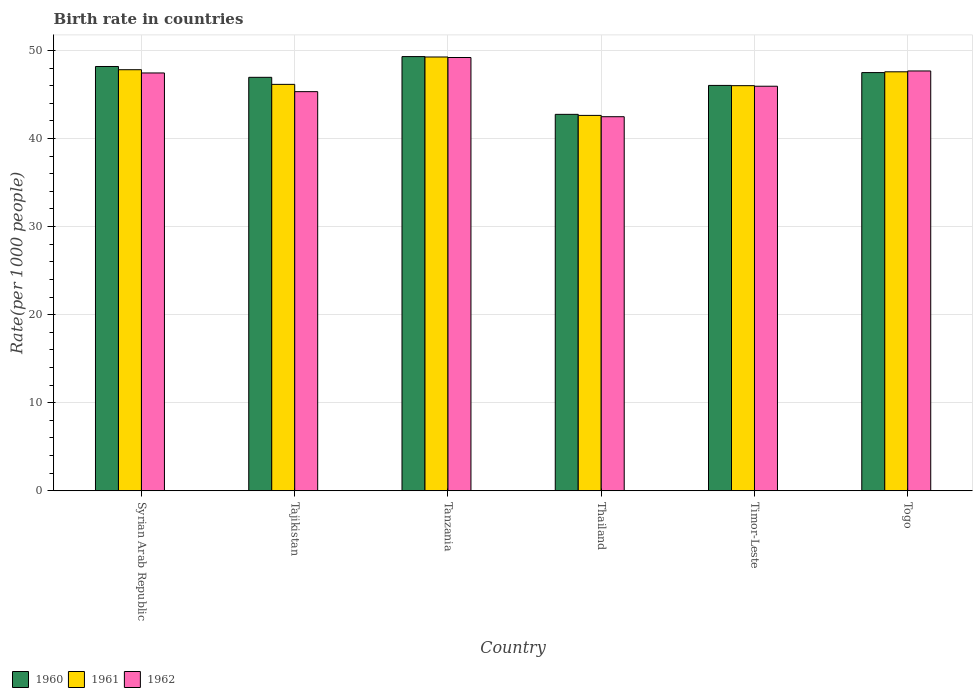How many different coloured bars are there?
Ensure brevity in your answer.  3. Are the number of bars per tick equal to the number of legend labels?
Your answer should be very brief. Yes. Are the number of bars on each tick of the X-axis equal?
Provide a short and direct response. Yes. How many bars are there on the 6th tick from the left?
Offer a terse response. 3. What is the label of the 5th group of bars from the left?
Your answer should be compact. Timor-Leste. What is the birth rate in 1962 in Thailand?
Give a very brief answer. 42.47. Across all countries, what is the maximum birth rate in 1960?
Your answer should be very brief. 49.3. Across all countries, what is the minimum birth rate in 1962?
Offer a very short reply. 42.47. In which country was the birth rate in 1961 maximum?
Your answer should be compact. Tanzania. In which country was the birth rate in 1960 minimum?
Provide a short and direct response. Thailand. What is the total birth rate in 1961 in the graph?
Your answer should be compact. 279.38. What is the difference between the birth rate in 1961 in Thailand and that in Togo?
Make the answer very short. -4.95. What is the difference between the birth rate in 1961 in Tajikistan and the birth rate in 1960 in Timor-Leste?
Provide a succinct answer. 0.12. What is the average birth rate in 1960 per country?
Provide a short and direct response. 46.77. What is the difference between the birth rate of/in 1962 and birth rate of/in 1960 in Tajikistan?
Offer a very short reply. -1.63. In how many countries, is the birth rate in 1962 greater than 46?
Provide a succinct answer. 3. What is the ratio of the birth rate in 1962 in Syrian Arab Republic to that in Thailand?
Your response must be concise. 1.12. Is the birth rate in 1961 in Syrian Arab Republic less than that in Tajikistan?
Your response must be concise. No. What is the difference between the highest and the second highest birth rate in 1962?
Offer a terse response. 1.75. What is the difference between the highest and the lowest birth rate in 1960?
Provide a short and direct response. 6.56. What does the 3rd bar from the right in Tanzania represents?
Provide a short and direct response. 1960. How many bars are there?
Provide a succinct answer. 18. Are all the bars in the graph horizontal?
Provide a short and direct response. No. What is the difference between two consecutive major ticks on the Y-axis?
Provide a succinct answer. 10. Does the graph contain any zero values?
Make the answer very short. No. How are the legend labels stacked?
Ensure brevity in your answer.  Horizontal. What is the title of the graph?
Ensure brevity in your answer.  Birth rate in countries. Does "1964" appear as one of the legend labels in the graph?
Your response must be concise. No. What is the label or title of the Y-axis?
Your answer should be compact. Rate(per 1000 people). What is the Rate(per 1000 people) of 1960 in Syrian Arab Republic?
Your response must be concise. 48.17. What is the Rate(per 1000 people) of 1961 in Syrian Arab Republic?
Your answer should be compact. 47.8. What is the Rate(per 1000 people) in 1962 in Syrian Arab Republic?
Give a very brief answer. 47.44. What is the Rate(per 1000 people) in 1960 in Tajikistan?
Your answer should be very brief. 46.94. What is the Rate(per 1000 people) in 1961 in Tajikistan?
Offer a very short reply. 46.14. What is the Rate(per 1000 people) of 1962 in Tajikistan?
Offer a terse response. 45.31. What is the Rate(per 1000 people) in 1960 in Tanzania?
Ensure brevity in your answer.  49.3. What is the Rate(per 1000 people) in 1961 in Tanzania?
Provide a short and direct response. 49.25. What is the Rate(per 1000 people) in 1962 in Tanzania?
Ensure brevity in your answer.  49.19. What is the Rate(per 1000 people) in 1960 in Thailand?
Offer a very short reply. 42.74. What is the Rate(per 1000 people) in 1961 in Thailand?
Make the answer very short. 42.62. What is the Rate(per 1000 people) in 1962 in Thailand?
Make the answer very short. 42.47. What is the Rate(per 1000 people) in 1960 in Timor-Leste?
Provide a short and direct response. 46.02. What is the Rate(per 1000 people) in 1961 in Timor-Leste?
Ensure brevity in your answer.  45.99. What is the Rate(per 1000 people) in 1962 in Timor-Leste?
Make the answer very short. 45.93. What is the Rate(per 1000 people) of 1960 in Togo?
Keep it short and to the point. 47.48. What is the Rate(per 1000 people) in 1961 in Togo?
Your answer should be compact. 47.57. What is the Rate(per 1000 people) in 1962 in Togo?
Make the answer very short. 47.66. Across all countries, what is the maximum Rate(per 1000 people) of 1960?
Your answer should be very brief. 49.3. Across all countries, what is the maximum Rate(per 1000 people) of 1961?
Ensure brevity in your answer.  49.25. Across all countries, what is the maximum Rate(per 1000 people) of 1962?
Your response must be concise. 49.19. Across all countries, what is the minimum Rate(per 1000 people) in 1960?
Give a very brief answer. 42.74. Across all countries, what is the minimum Rate(per 1000 people) in 1961?
Ensure brevity in your answer.  42.62. Across all countries, what is the minimum Rate(per 1000 people) in 1962?
Your response must be concise. 42.47. What is the total Rate(per 1000 people) of 1960 in the graph?
Offer a terse response. 280.65. What is the total Rate(per 1000 people) in 1961 in the graph?
Your response must be concise. 279.38. What is the total Rate(per 1000 people) of 1962 in the graph?
Ensure brevity in your answer.  278.01. What is the difference between the Rate(per 1000 people) in 1960 in Syrian Arab Republic and that in Tajikistan?
Ensure brevity in your answer.  1.23. What is the difference between the Rate(per 1000 people) in 1961 in Syrian Arab Republic and that in Tajikistan?
Keep it short and to the point. 1.66. What is the difference between the Rate(per 1000 people) in 1962 in Syrian Arab Republic and that in Tajikistan?
Your answer should be very brief. 2.12. What is the difference between the Rate(per 1000 people) in 1960 in Syrian Arab Republic and that in Tanzania?
Provide a succinct answer. -1.12. What is the difference between the Rate(per 1000 people) of 1961 in Syrian Arab Republic and that in Tanzania?
Offer a very short reply. -1.44. What is the difference between the Rate(per 1000 people) in 1962 in Syrian Arab Republic and that in Tanzania?
Give a very brief answer. -1.75. What is the difference between the Rate(per 1000 people) of 1960 in Syrian Arab Republic and that in Thailand?
Keep it short and to the point. 5.43. What is the difference between the Rate(per 1000 people) of 1961 in Syrian Arab Republic and that in Thailand?
Give a very brief answer. 5.19. What is the difference between the Rate(per 1000 people) in 1962 in Syrian Arab Republic and that in Thailand?
Keep it short and to the point. 4.97. What is the difference between the Rate(per 1000 people) of 1960 in Syrian Arab Republic and that in Timor-Leste?
Offer a terse response. 2.15. What is the difference between the Rate(per 1000 people) of 1961 in Syrian Arab Republic and that in Timor-Leste?
Your response must be concise. 1.81. What is the difference between the Rate(per 1000 people) of 1962 in Syrian Arab Republic and that in Timor-Leste?
Your answer should be compact. 1.51. What is the difference between the Rate(per 1000 people) in 1960 in Syrian Arab Republic and that in Togo?
Ensure brevity in your answer.  0.69. What is the difference between the Rate(per 1000 people) in 1961 in Syrian Arab Republic and that in Togo?
Make the answer very short. 0.24. What is the difference between the Rate(per 1000 people) of 1962 in Syrian Arab Republic and that in Togo?
Offer a very short reply. -0.23. What is the difference between the Rate(per 1000 people) of 1960 in Tajikistan and that in Tanzania?
Offer a terse response. -2.35. What is the difference between the Rate(per 1000 people) in 1961 in Tajikistan and that in Tanzania?
Your answer should be very brief. -3.11. What is the difference between the Rate(per 1000 people) of 1962 in Tajikistan and that in Tanzania?
Your answer should be very brief. -3.88. What is the difference between the Rate(per 1000 people) of 1960 in Tajikistan and that in Thailand?
Your answer should be compact. 4.21. What is the difference between the Rate(per 1000 people) in 1961 in Tajikistan and that in Thailand?
Keep it short and to the point. 3.52. What is the difference between the Rate(per 1000 people) of 1962 in Tajikistan and that in Thailand?
Provide a short and direct response. 2.85. What is the difference between the Rate(per 1000 people) of 1960 in Tajikistan and that in Timor-Leste?
Provide a short and direct response. 0.92. What is the difference between the Rate(per 1000 people) in 1961 in Tajikistan and that in Timor-Leste?
Give a very brief answer. 0.15. What is the difference between the Rate(per 1000 people) of 1962 in Tajikistan and that in Timor-Leste?
Your response must be concise. -0.61. What is the difference between the Rate(per 1000 people) in 1960 in Tajikistan and that in Togo?
Your answer should be compact. -0.54. What is the difference between the Rate(per 1000 people) in 1961 in Tajikistan and that in Togo?
Provide a succinct answer. -1.43. What is the difference between the Rate(per 1000 people) in 1962 in Tajikistan and that in Togo?
Offer a terse response. -2.35. What is the difference between the Rate(per 1000 people) in 1960 in Tanzania and that in Thailand?
Give a very brief answer. 6.56. What is the difference between the Rate(per 1000 people) in 1961 in Tanzania and that in Thailand?
Provide a succinct answer. 6.63. What is the difference between the Rate(per 1000 people) of 1962 in Tanzania and that in Thailand?
Make the answer very short. 6.72. What is the difference between the Rate(per 1000 people) in 1960 in Tanzania and that in Timor-Leste?
Provide a succinct answer. 3.27. What is the difference between the Rate(per 1000 people) in 1961 in Tanzania and that in Timor-Leste?
Offer a terse response. 3.25. What is the difference between the Rate(per 1000 people) of 1962 in Tanzania and that in Timor-Leste?
Your answer should be very brief. 3.26. What is the difference between the Rate(per 1000 people) of 1960 in Tanzania and that in Togo?
Ensure brevity in your answer.  1.82. What is the difference between the Rate(per 1000 people) of 1961 in Tanzania and that in Togo?
Your answer should be compact. 1.68. What is the difference between the Rate(per 1000 people) in 1962 in Tanzania and that in Togo?
Your response must be concise. 1.53. What is the difference between the Rate(per 1000 people) of 1960 in Thailand and that in Timor-Leste?
Keep it short and to the point. -3.29. What is the difference between the Rate(per 1000 people) in 1961 in Thailand and that in Timor-Leste?
Give a very brief answer. -3.38. What is the difference between the Rate(per 1000 people) of 1962 in Thailand and that in Timor-Leste?
Give a very brief answer. -3.46. What is the difference between the Rate(per 1000 people) of 1960 in Thailand and that in Togo?
Your answer should be very brief. -4.74. What is the difference between the Rate(per 1000 people) of 1961 in Thailand and that in Togo?
Offer a terse response. -4.95. What is the difference between the Rate(per 1000 people) in 1962 in Thailand and that in Togo?
Your answer should be compact. -5.19. What is the difference between the Rate(per 1000 people) of 1960 in Timor-Leste and that in Togo?
Provide a succinct answer. -1.46. What is the difference between the Rate(per 1000 people) of 1961 in Timor-Leste and that in Togo?
Offer a very short reply. -1.57. What is the difference between the Rate(per 1000 people) of 1962 in Timor-Leste and that in Togo?
Your answer should be compact. -1.73. What is the difference between the Rate(per 1000 people) of 1960 in Syrian Arab Republic and the Rate(per 1000 people) of 1961 in Tajikistan?
Provide a short and direct response. 2.03. What is the difference between the Rate(per 1000 people) of 1960 in Syrian Arab Republic and the Rate(per 1000 people) of 1962 in Tajikistan?
Offer a terse response. 2.86. What is the difference between the Rate(per 1000 people) in 1961 in Syrian Arab Republic and the Rate(per 1000 people) in 1962 in Tajikistan?
Ensure brevity in your answer.  2.49. What is the difference between the Rate(per 1000 people) of 1960 in Syrian Arab Republic and the Rate(per 1000 people) of 1961 in Tanzania?
Offer a terse response. -1.08. What is the difference between the Rate(per 1000 people) in 1960 in Syrian Arab Republic and the Rate(per 1000 people) in 1962 in Tanzania?
Provide a succinct answer. -1.02. What is the difference between the Rate(per 1000 people) in 1961 in Syrian Arab Republic and the Rate(per 1000 people) in 1962 in Tanzania?
Your answer should be very brief. -1.39. What is the difference between the Rate(per 1000 people) in 1960 in Syrian Arab Republic and the Rate(per 1000 people) in 1961 in Thailand?
Your answer should be compact. 5.55. What is the difference between the Rate(per 1000 people) of 1960 in Syrian Arab Republic and the Rate(per 1000 people) of 1962 in Thailand?
Make the answer very short. 5.7. What is the difference between the Rate(per 1000 people) of 1961 in Syrian Arab Republic and the Rate(per 1000 people) of 1962 in Thailand?
Make the answer very short. 5.33. What is the difference between the Rate(per 1000 people) of 1960 in Syrian Arab Republic and the Rate(per 1000 people) of 1961 in Timor-Leste?
Your answer should be compact. 2.18. What is the difference between the Rate(per 1000 people) of 1960 in Syrian Arab Republic and the Rate(per 1000 people) of 1962 in Timor-Leste?
Your response must be concise. 2.24. What is the difference between the Rate(per 1000 people) of 1961 in Syrian Arab Republic and the Rate(per 1000 people) of 1962 in Timor-Leste?
Give a very brief answer. 1.88. What is the difference between the Rate(per 1000 people) in 1960 in Syrian Arab Republic and the Rate(per 1000 people) in 1961 in Togo?
Give a very brief answer. 0.6. What is the difference between the Rate(per 1000 people) in 1960 in Syrian Arab Republic and the Rate(per 1000 people) in 1962 in Togo?
Offer a terse response. 0.51. What is the difference between the Rate(per 1000 people) in 1961 in Syrian Arab Republic and the Rate(per 1000 people) in 1962 in Togo?
Keep it short and to the point. 0.14. What is the difference between the Rate(per 1000 people) of 1960 in Tajikistan and the Rate(per 1000 people) of 1961 in Tanzania?
Your answer should be compact. -2.31. What is the difference between the Rate(per 1000 people) in 1960 in Tajikistan and the Rate(per 1000 people) in 1962 in Tanzania?
Your answer should be compact. -2.25. What is the difference between the Rate(per 1000 people) in 1961 in Tajikistan and the Rate(per 1000 people) in 1962 in Tanzania?
Your answer should be compact. -3.05. What is the difference between the Rate(per 1000 people) in 1960 in Tajikistan and the Rate(per 1000 people) in 1961 in Thailand?
Offer a very short reply. 4.32. What is the difference between the Rate(per 1000 people) in 1960 in Tajikistan and the Rate(per 1000 people) in 1962 in Thailand?
Offer a terse response. 4.47. What is the difference between the Rate(per 1000 people) in 1961 in Tajikistan and the Rate(per 1000 people) in 1962 in Thailand?
Provide a short and direct response. 3.67. What is the difference between the Rate(per 1000 people) in 1960 in Tajikistan and the Rate(per 1000 people) in 1961 in Timor-Leste?
Your answer should be very brief. 0.95. What is the difference between the Rate(per 1000 people) in 1960 in Tajikistan and the Rate(per 1000 people) in 1962 in Timor-Leste?
Provide a short and direct response. 1.01. What is the difference between the Rate(per 1000 people) in 1961 in Tajikistan and the Rate(per 1000 people) in 1962 in Timor-Leste?
Your answer should be compact. 0.21. What is the difference between the Rate(per 1000 people) in 1960 in Tajikistan and the Rate(per 1000 people) in 1961 in Togo?
Offer a very short reply. -0.63. What is the difference between the Rate(per 1000 people) of 1960 in Tajikistan and the Rate(per 1000 people) of 1962 in Togo?
Make the answer very short. -0.72. What is the difference between the Rate(per 1000 people) in 1961 in Tajikistan and the Rate(per 1000 people) in 1962 in Togo?
Offer a terse response. -1.52. What is the difference between the Rate(per 1000 people) in 1960 in Tanzania and the Rate(per 1000 people) in 1961 in Thailand?
Give a very brief answer. 6.68. What is the difference between the Rate(per 1000 people) in 1960 in Tanzania and the Rate(per 1000 people) in 1962 in Thailand?
Your answer should be compact. 6.83. What is the difference between the Rate(per 1000 people) in 1961 in Tanzania and the Rate(per 1000 people) in 1962 in Thailand?
Offer a terse response. 6.78. What is the difference between the Rate(per 1000 people) in 1960 in Tanzania and the Rate(per 1000 people) in 1961 in Timor-Leste?
Provide a succinct answer. 3.3. What is the difference between the Rate(per 1000 people) of 1960 in Tanzania and the Rate(per 1000 people) of 1962 in Timor-Leste?
Make the answer very short. 3.37. What is the difference between the Rate(per 1000 people) in 1961 in Tanzania and the Rate(per 1000 people) in 1962 in Timor-Leste?
Your response must be concise. 3.32. What is the difference between the Rate(per 1000 people) of 1960 in Tanzania and the Rate(per 1000 people) of 1961 in Togo?
Your answer should be very brief. 1.73. What is the difference between the Rate(per 1000 people) of 1960 in Tanzania and the Rate(per 1000 people) of 1962 in Togo?
Give a very brief answer. 1.63. What is the difference between the Rate(per 1000 people) of 1961 in Tanzania and the Rate(per 1000 people) of 1962 in Togo?
Make the answer very short. 1.59. What is the difference between the Rate(per 1000 people) of 1960 in Thailand and the Rate(per 1000 people) of 1961 in Timor-Leste?
Offer a terse response. -3.26. What is the difference between the Rate(per 1000 people) in 1960 in Thailand and the Rate(per 1000 people) in 1962 in Timor-Leste?
Provide a short and direct response. -3.19. What is the difference between the Rate(per 1000 people) of 1961 in Thailand and the Rate(per 1000 people) of 1962 in Timor-Leste?
Provide a succinct answer. -3.31. What is the difference between the Rate(per 1000 people) of 1960 in Thailand and the Rate(per 1000 people) of 1961 in Togo?
Your answer should be very brief. -4.83. What is the difference between the Rate(per 1000 people) of 1960 in Thailand and the Rate(per 1000 people) of 1962 in Togo?
Make the answer very short. -4.93. What is the difference between the Rate(per 1000 people) in 1961 in Thailand and the Rate(per 1000 people) in 1962 in Togo?
Your answer should be very brief. -5.04. What is the difference between the Rate(per 1000 people) in 1960 in Timor-Leste and the Rate(per 1000 people) in 1961 in Togo?
Your response must be concise. -1.54. What is the difference between the Rate(per 1000 people) of 1960 in Timor-Leste and the Rate(per 1000 people) of 1962 in Togo?
Make the answer very short. -1.64. What is the difference between the Rate(per 1000 people) in 1961 in Timor-Leste and the Rate(per 1000 people) in 1962 in Togo?
Keep it short and to the point. -1.67. What is the average Rate(per 1000 people) of 1960 per country?
Ensure brevity in your answer.  46.77. What is the average Rate(per 1000 people) in 1961 per country?
Offer a very short reply. 46.56. What is the average Rate(per 1000 people) in 1962 per country?
Give a very brief answer. 46.33. What is the difference between the Rate(per 1000 people) of 1960 and Rate(per 1000 people) of 1961 in Syrian Arab Republic?
Offer a terse response. 0.37. What is the difference between the Rate(per 1000 people) in 1960 and Rate(per 1000 people) in 1962 in Syrian Arab Republic?
Keep it short and to the point. 0.73. What is the difference between the Rate(per 1000 people) of 1961 and Rate(per 1000 people) of 1962 in Syrian Arab Republic?
Keep it short and to the point. 0.37. What is the difference between the Rate(per 1000 people) of 1960 and Rate(per 1000 people) of 1962 in Tajikistan?
Provide a short and direct response. 1.63. What is the difference between the Rate(per 1000 people) of 1961 and Rate(per 1000 people) of 1962 in Tajikistan?
Your answer should be compact. 0.83. What is the difference between the Rate(per 1000 people) in 1960 and Rate(per 1000 people) in 1961 in Tanzania?
Make the answer very short. 0.05. What is the difference between the Rate(per 1000 people) of 1960 and Rate(per 1000 people) of 1962 in Tanzania?
Make the answer very short. 0.1. What is the difference between the Rate(per 1000 people) of 1961 and Rate(per 1000 people) of 1962 in Tanzania?
Ensure brevity in your answer.  0.06. What is the difference between the Rate(per 1000 people) of 1960 and Rate(per 1000 people) of 1961 in Thailand?
Provide a short and direct response. 0.12. What is the difference between the Rate(per 1000 people) in 1960 and Rate(per 1000 people) in 1962 in Thailand?
Offer a very short reply. 0.27. What is the difference between the Rate(per 1000 people) of 1961 and Rate(per 1000 people) of 1962 in Thailand?
Offer a terse response. 0.15. What is the difference between the Rate(per 1000 people) of 1960 and Rate(per 1000 people) of 1961 in Timor-Leste?
Make the answer very short. 0.03. What is the difference between the Rate(per 1000 people) of 1960 and Rate(per 1000 people) of 1962 in Timor-Leste?
Offer a terse response. 0.09. What is the difference between the Rate(per 1000 people) in 1961 and Rate(per 1000 people) in 1962 in Timor-Leste?
Offer a terse response. 0.06. What is the difference between the Rate(per 1000 people) in 1960 and Rate(per 1000 people) in 1961 in Togo?
Ensure brevity in your answer.  -0.09. What is the difference between the Rate(per 1000 people) of 1960 and Rate(per 1000 people) of 1962 in Togo?
Offer a very short reply. -0.18. What is the difference between the Rate(per 1000 people) of 1961 and Rate(per 1000 people) of 1962 in Togo?
Provide a short and direct response. -0.1. What is the ratio of the Rate(per 1000 people) of 1960 in Syrian Arab Republic to that in Tajikistan?
Your response must be concise. 1.03. What is the ratio of the Rate(per 1000 people) in 1961 in Syrian Arab Republic to that in Tajikistan?
Give a very brief answer. 1.04. What is the ratio of the Rate(per 1000 people) in 1962 in Syrian Arab Republic to that in Tajikistan?
Ensure brevity in your answer.  1.05. What is the ratio of the Rate(per 1000 people) of 1960 in Syrian Arab Republic to that in Tanzania?
Your answer should be very brief. 0.98. What is the ratio of the Rate(per 1000 people) in 1961 in Syrian Arab Republic to that in Tanzania?
Your answer should be compact. 0.97. What is the ratio of the Rate(per 1000 people) of 1962 in Syrian Arab Republic to that in Tanzania?
Provide a short and direct response. 0.96. What is the ratio of the Rate(per 1000 people) of 1960 in Syrian Arab Republic to that in Thailand?
Your response must be concise. 1.13. What is the ratio of the Rate(per 1000 people) of 1961 in Syrian Arab Republic to that in Thailand?
Provide a short and direct response. 1.12. What is the ratio of the Rate(per 1000 people) in 1962 in Syrian Arab Republic to that in Thailand?
Give a very brief answer. 1.12. What is the ratio of the Rate(per 1000 people) in 1960 in Syrian Arab Republic to that in Timor-Leste?
Provide a succinct answer. 1.05. What is the ratio of the Rate(per 1000 people) in 1961 in Syrian Arab Republic to that in Timor-Leste?
Your answer should be compact. 1.04. What is the ratio of the Rate(per 1000 people) of 1962 in Syrian Arab Republic to that in Timor-Leste?
Your answer should be compact. 1.03. What is the ratio of the Rate(per 1000 people) in 1960 in Syrian Arab Republic to that in Togo?
Make the answer very short. 1.01. What is the ratio of the Rate(per 1000 people) in 1962 in Syrian Arab Republic to that in Togo?
Ensure brevity in your answer.  1. What is the ratio of the Rate(per 1000 people) in 1960 in Tajikistan to that in Tanzania?
Provide a short and direct response. 0.95. What is the ratio of the Rate(per 1000 people) of 1961 in Tajikistan to that in Tanzania?
Provide a succinct answer. 0.94. What is the ratio of the Rate(per 1000 people) of 1962 in Tajikistan to that in Tanzania?
Give a very brief answer. 0.92. What is the ratio of the Rate(per 1000 people) of 1960 in Tajikistan to that in Thailand?
Your response must be concise. 1.1. What is the ratio of the Rate(per 1000 people) of 1961 in Tajikistan to that in Thailand?
Keep it short and to the point. 1.08. What is the ratio of the Rate(per 1000 people) in 1962 in Tajikistan to that in Thailand?
Your response must be concise. 1.07. What is the ratio of the Rate(per 1000 people) in 1961 in Tajikistan to that in Timor-Leste?
Offer a very short reply. 1. What is the ratio of the Rate(per 1000 people) in 1962 in Tajikistan to that in Timor-Leste?
Your answer should be very brief. 0.99. What is the ratio of the Rate(per 1000 people) of 1960 in Tajikistan to that in Togo?
Offer a very short reply. 0.99. What is the ratio of the Rate(per 1000 people) in 1961 in Tajikistan to that in Togo?
Provide a succinct answer. 0.97. What is the ratio of the Rate(per 1000 people) in 1962 in Tajikistan to that in Togo?
Ensure brevity in your answer.  0.95. What is the ratio of the Rate(per 1000 people) of 1960 in Tanzania to that in Thailand?
Your answer should be compact. 1.15. What is the ratio of the Rate(per 1000 people) in 1961 in Tanzania to that in Thailand?
Ensure brevity in your answer.  1.16. What is the ratio of the Rate(per 1000 people) of 1962 in Tanzania to that in Thailand?
Your answer should be compact. 1.16. What is the ratio of the Rate(per 1000 people) in 1960 in Tanzania to that in Timor-Leste?
Offer a terse response. 1.07. What is the ratio of the Rate(per 1000 people) of 1961 in Tanzania to that in Timor-Leste?
Offer a very short reply. 1.07. What is the ratio of the Rate(per 1000 people) in 1962 in Tanzania to that in Timor-Leste?
Ensure brevity in your answer.  1.07. What is the ratio of the Rate(per 1000 people) in 1960 in Tanzania to that in Togo?
Ensure brevity in your answer.  1.04. What is the ratio of the Rate(per 1000 people) of 1961 in Tanzania to that in Togo?
Give a very brief answer. 1.04. What is the ratio of the Rate(per 1000 people) of 1962 in Tanzania to that in Togo?
Provide a short and direct response. 1.03. What is the ratio of the Rate(per 1000 people) in 1960 in Thailand to that in Timor-Leste?
Your answer should be compact. 0.93. What is the ratio of the Rate(per 1000 people) in 1961 in Thailand to that in Timor-Leste?
Offer a very short reply. 0.93. What is the ratio of the Rate(per 1000 people) in 1962 in Thailand to that in Timor-Leste?
Make the answer very short. 0.92. What is the ratio of the Rate(per 1000 people) of 1960 in Thailand to that in Togo?
Keep it short and to the point. 0.9. What is the ratio of the Rate(per 1000 people) of 1961 in Thailand to that in Togo?
Your answer should be compact. 0.9. What is the ratio of the Rate(per 1000 people) in 1962 in Thailand to that in Togo?
Offer a very short reply. 0.89. What is the ratio of the Rate(per 1000 people) in 1960 in Timor-Leste to that in Togo?
Make the answer very short. 0.97. What is the ratio of the Rate(per 1000 people) in 1961 in Timor-Leste to that in Togo?
Your answer should be very brief. 0.97. What is the ratio of the Rate(per 1000 people) in 1962 in Timor-Leste to that in Togo?
Give a very brief answer. 0.96. What is the difference between the highest and the second highest Rate(per 1000 people) of 1960?
Give a very brief answer. 1.12. What is the difference between the highest and the second highest Rate(per 1000 people) in 1961?
Offer a very short reply. 1.44. What is the difference between the highest and the second highest Rate(per 1000 people) of 1962?
Offer a terse response. 1.53. What is the difference between the highest and the lowest Rate(per 1000 people) of 1960?
Your answer should be very brief. 6.56. What is the difference between the highest and the lowest Rate(per 1000 people) in 1961?
Provide a short and direct response. 6.63. What is the difference between the highest and the lowest Rate(per 1000 people) in 1962?
Give a very brief answer. 6.72. 